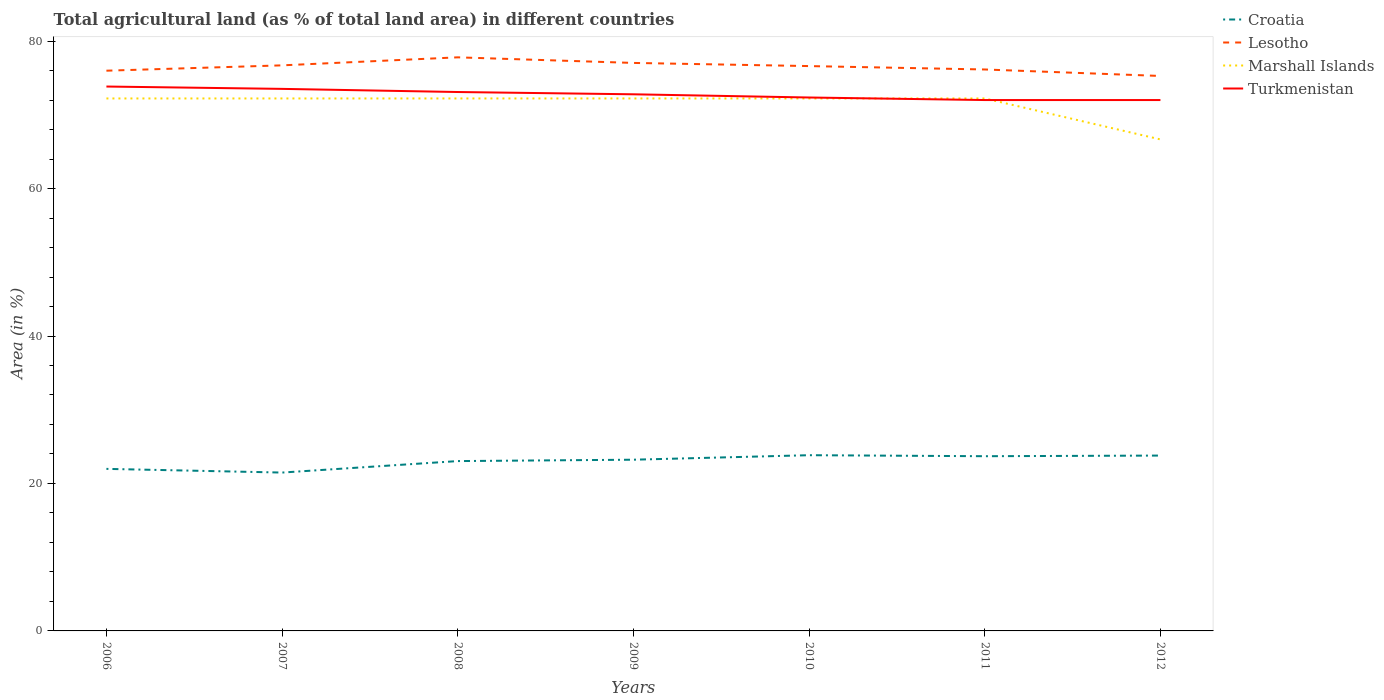Does the line corresponding to Lesotho intersect with the line corresponding to Marshall Islands?
Make the answer very short. No. Across all years, what is the maximum percentage of agricultural land in Marshall Islands?
Your answer should be very brief. 66.67. What is the total percentage of agricultural land in Lesotho in the graph?
Keep it short and to the point. -0.33. What is the difference between the highest and the second highest percentage of agricultural land in Marshall Islands?
Provide a succinct answer. 5.56. What is the difference between the highest and the lowest percentage of agricultural land in Croatia?
Make the answer very short. 5. Is the percentage of agricultural land in Lesotho strictly greater than the percentage of agricultural land in Croatia over the years?
Your answer should be compact. No. How many lines are there?
Offer a terse response. 4. How many years are there in the graph?
Provide a succinct answer. 7. Does the graph contain any zero values?
Offer a terse response. No. How many legend labels are there?
Give a very brief answer. 4. How are the legend labels stacked?
Your response must be concise. Vertical. What is the title of the graph?
Give a very brief answer. Total agricultural land (as % of total land area) in different countries. What is the label or title of the Y-axis?
Offer a very short reply. Area (in %). What is the Area (in %) in Croatia in 2006?
Your answer should be compact. 21.98. What is the Area (in %) of Lesotho in 2006?
Provide a short and direct response. 75.99. What is the Area (in %) of Marshall Islands in 2006?
Your answer should be very brief. 72.22. What is the Area (in %) of Turkmenistan in 2006?
Offer a terse response. 73.84. What is the Area (in %) of Croatia in 2007?
Provide a succinct answer. 21.48. What is the Area (in %) in Lesotho in 2007?
Provide a short and direct response. 76.71. What is the Area (in %) of Marshall Islands in 2007?
Your answer should be very brief. 72.22. What is the Area (in %) in Turkmenistan in 2007?
Offer a very short reply. 73.52. What is the Area (in %) in Croatia in 2008?
Provide a short and direct response. 23.04. What is the Area (in %) in Lesotho in 2008?
Your answer should be very brief. 77.8. What is the Area (in %) in Marshall Islands in 2008?
Your answer should be compact. 72.22. What is the Area (in %) of Turkmenistan in 2008?
Offer a terse response. 73.1. What is the Area (in %) in Croatia in 2009?
Make the answer very short. 23.22. What is the Area (in %) of Lesotho in 2009?
Make the answer very short. 77.04. What is the Area (in %) of Marshall Islands in 2009?
Your answer should be compact. 72.22. What is the Area (in %) in Turkmenistan in 2009?
Your response must be concise. 72.79. What is the Area (in %) of Croatia in 2010?
Ensure brevity in your answer.  23.83. What is the Area (in %) of Lesotho in 2010?
Keep it short and to the point. 76.61. What is the Area (in %) in Marshall Islands in 2010?
Provide a succinct answer. 72.22. What is the Area (in %) in Turkmenistan in 2010?
Offer a very short reply. 72.35. What is the Area (in %) of Croatia in 2011?
Your answer should be compact. 23.7. What is the Area (in %) of Lesotho in 2011?
Make the answer very short. 76.15. What is the Area (in %) of Marshall Islands in 2011?
Keep it short and to the point. 72.22. What is the Area (in %) of Turkmenistan in 2011?
Offer a terse response. 72.01. What is the Area (in %) in Croatia in 2012?
Make the answer very short. 23.78. What is the Area (in %) of Lesotho in 2012?
Your answer should be very brief. 75.27. What is the Area (in %) of Marshall Islands in 2012?
Offer a very short reply. 66.67. What is the Area (in %) of Turkmenistan in 2012?
Your answer should be very brief. 72.01. Across all years, what is the maximum Area (in %) of Croatia?
Give a very brief answer. 23.83. Across all years, what is the maximum Area (in %) in Lesotho?
Make the answer very short. 77.8. Across all years, what is the maximum Area (in %) of Marshall Islands?
Offer a terse response. 72.22. Across all years, what is the maximum Area (in %) in Turkmenistan?
Ensure brevity in your answer.  73.84. Across all years, what is the minimum Area (in %) in Croatia?
Ensure brevity in your answer.  21.48. Across all years, what is the minimum Area (in %) in Lesotho?
Ensure brevity in your answer.  75.27. Across all years, what is the minimum Area (in %) in Marshall Islands?
Provide a short and direct response. 66.67. Across all years, what is the minimum Area (in %) of Turkmenistan?
Offer a very short reply. 72.01. What is the total Area (in %) of Croatia in the graph?
Provide a succinct answer. 161.04. What is the total Area (in %) of Lesotho in the graph?
Offer a terse response. 535.58. What is the total Area (in %) of Marshall Islands in the graph?
Offer a very short reply. 500. What is the total Area (in %) of Turkmenistan in the graph?
Make the answer very short. 509.61. What is the difference between the Area (in %) of Croatia in 2006 and that in 2007?
Provide a succinct answer. 0.5. What is the difference between the Area (in %) in Lesotho in 2006 and that in 2007?
Provide a succinct answer. -0.72. What is the difference between the Area (in %) of Marshall Islands in 2006 and that in 2007?
Your answer should be compact. 0. What is the difference between the Area (in %) of Turkmenistan in 2006 and that in 2007?
Offer a very short reply. 0.32. What is the difference between the Area (in %) in Croatia in 2006 and that in 2008?
Offer a very short reply. -1.06. What is the difference between the Area (in %) of Lesotho in 2006 and that in 2008?
Your response must be concise. -1.81. What is the difference between the Area (in %) of Marshall Islands in 2006 and that in 2008?
Provide a succinct answer. 0. What is the difference between the Area (in %) in Turkmenistan in 2006 and that in 2008?
Keep it short and to the point. 0.74. What is the difference between the Area (in %) of Croatia in 2006 and that in 2009?
Your answer should be very brief. -1.24. What is the difference between the Area (in %) of Lesotho in 2006 and that in 2009?
Keep it short and to the point. -1.05. What is the difference between the Area (in %) in Turkmenistan in 2006 and that in 2009?
Keep it short and to the point. 1.05. What is the difference between the Area (in %) of Croatia in 2006 and that in 2010?
Provide a short and direct response. -1.85. What is the difference between the Area (in %) in Lesotho in 2006 and that in 2010?
Offer a terse response. -0.63. What is the difference between the Area (in %) of Marshall Islands in 2006 and that in 2010?
Keep it short and to the point. 0. What is the difference between the Area (in %) in Turkmenistan in 2006 and that in 2010?
Give a very brief answer. 1.49. What is the difference between the Area (in %) in Croatia in 2006 and that in 2011?
Your answer should be very brief. -1.72. What is the difference between the Area (in %) in Lesotho in 2006 and that in 2011?
Provide a short and direct response. -0.16. What is the difference between the Area (in %) of Marshall Islands in 2006 and that in 2011?
Give a very brief answer. 0. What is the difference between the Area (in %) in Turkmenistan in 2006 and that in 2011?
Keep it short and to the point. 1.83. What is the difference between the Area (in %) in Croatia in 2006 and that in 2012?
Make the answer very short. -1.8. What is the difference between the Area (in %) of Lesotho in 2006 and that in 2012?
Provide a short and direct response. 0.71. What is the difference between the Area (in %) in Marshall Islands in 2006 and that in 2012?
Keep it short and to the point. 5.56. What is the difference between the Area (in %) in Turkmenistan in 2006 and that in 2012?
Your answer should be compact. 1.83. What is the difference between the Area (in %) of Croatia in 2007 and that in 2008?
Ensure brevity in your answer.  -1.56. What is the difference between the Area (in %) in Lesotho in 2007 and that in 2008?
Provide a succinct answer. -1.09. What is the difference between the Area (in %) in Marshall Islands in 2007 and that in 2008?
Give a very brief answer. 0. What is the difference between the Area (in %) in Turkmenistan in 2007 and that in 2008?
Your answer should be compact. 0.43. What is the difference between the Area (in %) of Croatia in 2007 and that in 2009?
Make the answer very short. -1.74. What is the difference between the Area (in %) of Lesotho in 2007 and that in 2009?
Your answer should be very brief. -0.33. What is the difference between the Area (in %) in Turkmenistan in 2007 and that in 2009?
Keep it short and to the point. 0.73. What is the difference between the Area (in %) of Croatia in 2007 and that in 2010?
Provide a succinct answer. -2.36. What is the difference between the Area (in %) in Lesotho in 2007 and that in 2010?
Ensure brevity in your answer.  0.1. What is the difference between the Area (in %) of Marshall Islands in 2007 and that in 2010?
Your answer should be compact. 0. What is the difference between the Area (in %) of Turkmenistan in 2007 and that in 2010?
Your answer should be compact. 1.17. What is the difference between the Area (in %) in Croatia in 2007 and that in 2011?
Provide a short and direct response. -2.22. What is the difference between the Area (in %) of Lesotho in 2007 and that in 2011?
Your answer should be very brief. 0.56. What is the difference between the Area (in %) of Marshall Islands in 2007 and that in 2011?
Your answer should be compact. 0. What is the difference between the Area (in %) in Turkmenistan in 2007 and that in 2011?
Your answer should be compact. 1.52. What is the difference between the Area (in %) of Croatia in 2007 and that in 2012?
Your answer should be very brief. -2.31. What is the difference between the Area (in %) in Lesotho in 2007 and that in 2012?
Provide a succinct answer. 1.44. What is the difference between the Area (in %) of Marshall Islands in 2007 and that in 2012?
Keep it short and to the point. 5.56. What is the difference between the Area (in %) of Turkmenistan in 2007 and that in 2012?
Your answer should be compact. 1.52. What is the difference between the Area (in %) of Croatia in 2008 and that in 2009?
Make the answer very short. -0.19. What is the difference between the Area (in %) of Lesotho in 2008 and that in 2009?
Make the answer very short. 0.76. What is the difference between the Area (in %) of Turkmenistan in 2008 and that in 2009?
Offer a terse response. 0.31. What is the difference between the Area (in %) of Croatia in 2008 and that in 2010?
Provide a succinct answer. -0.8. What is the difference between the Area (in %) of Lesotho in 2008 and that in 2010?
Provide a succinct answer. 1.19. What is the difference between the Area (in %) of Turkmenistan in 2008 and that in 2010?
Your response must be concise. 0.74. What is the difference between the Area (in %) of Croatia in 2008 and that in 2011?
Provide a succinct answer. -0.66. What is the difference between the Area (in %) of Lesotho in 2008 and that in 2011?
Ensure brevity in your answer.  1.65. What is the difference between the Area (in %) in Marshall Islands in 2008 and that in 2011?
Your response must be concise. 0. What is the difference between the Area (in %) of Turkmenistan in 2008 and that in 2011?
Provide a succinct answer. 1.09. What is the difference between the Area (in %) of Croatia in 2008 and that in 2012?
Your answer should be very brief. -0.75. What is the difference between the Area (in %) of Lesotho in 2008 and that in 2012?
Your response must be concise. 2.53. What is the difference between the Area (in %) of Marshall Islands in 2008 and that in 2012?
Your answer should be very brief. 5.56. What is the difference between the Area (in %) of Turkmenistan in 2008 and that in 2012?
Offer a very short reply. 1.09. What is the difference between the Area (in %) of Croatia in 2009 and that in 2010?
Provide a short and direct response. -0.61. What is the difference between the Area (in %) of Lesotho in 2009 and that in 2010?
Offer a very short reply. 0.43. What is the difference between the Area (in %) of Turkmenistan in 2009 and that in 2010?
Your response must be concise. 0.44. What is the difference between the Area (in %) in Croatia in 2009 and that in 2011?
Make the answer very short. -0.47. What is the difference between the Area (in %) in Lesotho in 2009 and that in 2011?
Ensure brevity in your answer.  0.89. What is the difference between the Area (in %) in Turkmenistan in 2009 and that in 2011?
Offer a very short reply. 0.78. What is the difference between the Area (in %) of Croatia in 2009 and that in 2012?
Offer a very short reply. -0.56. What is the difference between the Area (in %) in Lesotho in 2009 and that in 2012?
Your answer should be compact. 1.77. What is the difference between the Area (in %) in Marshall Islands in 2009 and that in 2012?
Offer a terse response. 5.56. What is the difference between the Area (in %) in Turkmenistan in 2009 and that in 2012?
Offer a terse response. 0.78. What is the difference between the Area (in %) in Croatia in 2010 and that in 2011?
Give a very brief answer. 0.14. What is the difference between the Area (in %) in Lesotho in 2010 and that in 2011?
Provide a short and direct response. 0.46. What is the difference between the Area (in %) of Marshall Islands in 2010 and that in 2011?
Ensure brevity in your answer.  0. What is the difference between the Area (in %) in Turkmenistan in 2010 and that in 2011?
Offer a very short reply. 0.34. What is the difference between the Area (in %) of Croatia in 2010 and that in 2012?
Provide a succinct answer. 0.05. What is the difference between the Area (in %) of Lesotho in 2010 and that in 2012?
Give a very brief answer. 1.34. What is the difference between the Area (in %) of Marshall Islands in 2010 and that in 2012?
Provide a short and direct response. 5.56. What is the difference between the Area (in %) in Turkmenistan in 2010 and that in 2012?
Provide a short and direct response. 0.34. What is the difference between the Area (in %) in Croatia in 2011 and that in 2012?
Ensure brevity in your answer.  -0.09. What is the difference between the Area (in %) in Lesotho in 2011 and that in 2012?
Provide a short and direct response. 0.88. What is the difference between the Area (in %) of Marshall Islands in 2011 and that in 2012?
Ensure brevity in your answer.  5.56. What is the difference between the Area (in %) in Turkmenistan in 2011 and that in 2012?
Give a very brief answer. 0. What is the difference between the Area (in %) of Croatia in 2006 and the Area (in %) of Lesotho in 2007?
Offer a very short reply. -54.73. What is the difference between the Area (in %) of Croatia in 2006 and the Area (in %) of Marshall Islands in 2007?
Offer a very short reply. -50.24. What is the difference between the Area (in %) of Croatia in 2006 and the Area (in %) of Turkmenistan in 2007?
Your answer should be very brief. -51.54. What is the difference between the Area (in %) in Lesotho in 2006 and the Area (in %) in Marshall Islands in 2007?
Provide a short and direct response. 3.77. What is the difference between the Area (in %) in Lesotho in 2006 and the Area (in %) in Turkmenistan in 2007?
Provide a succinct answer. 2.47. What is the difference between the Area (in %) in Marshall Islands in 2006 and the Area (in %) in Turkmenistan in 2007?
Your answer should be compact. -1.3. What is the difference between the Area (in %) in Croatia in 2006 and the Area (in %) in Lesotho in 2008?
Provide a succinct answer. -55.82. What is the difference between the Area (in %) of Croatia in 2006 and the Area (in %) of Marshall Islands in 2008?
Your answer should be compact. -50.24. What is the difference between the Area (in %) of Croatia in 2006 and the Area (in %) of Turkmenistan in 2008?
Your answer should be very brief. -51.12. What is the difference between the Area (in %) in Lesotho in 2006 and the Area (in %) in Marshall Islands in 2008?
Your answer should be compact. 3.77. What is the difference between the Area (in %) in Lesotho in 2006 and the Area (in %) in Turkmenistan in 2008?
Your answer should be very brief. 2.89. What is the difference between the Area (in %) in Marshall Islands in 2006 and the Area (in %) in Turkmenistan in 2008?
Provide a succinct answer. -0.87. What is the difference between the Area (in %) of Croatia in 2006 and the Area (in %) of Lesotho in 2009?
Your response must be concise. -55.06. What is the difference between the Area (in %) in Croatia in 2006 and the Area (in %) in Marshall Islands in 2009?
Your answer should be very brief. -50.24. What is the difference between the Area (in %) in Croatia in 2006 and the Area (in %) in Turkmenistan in 2009?
Your response must be concise. -50.81. What is the difference between the Area (in %) of Lesotho in 2006 and the Area (in %) of Marshall Islands in 2009?
Ensure brevity in your answer.  3.77. What is the difference between the Area (in %) of Lesotho in 2006 and the Area (in %) of Turkmenistan in 2009?
Your answer should be compact. 3.2. What is the difference between the Area (in %) in Marshall Islands in 2006 and the Area (in %) in Turkmenistan in 2009?
Make the answer very short. -0.57. What is the difference between the Area (in %) of Croatia in 2006 and the Area (in %) of Lesotho in 2010?
Give a very brief answer. -54.63. What is the difference between the Area (in %) in Croatia in 2006 and the Area (in %) in Marshall Islands in 2010?
Provide a short and direct response. -50.24. What is the difference between the Area (in %) of Croatia in 2006 and the Area (in %) of Turkmenistan in 2010?
Your response must be concise. -50.37. What is the difference between the Area (in %) of Lesotho in 2006 and the Area (in %) of Marshall Islands in 2010?
Ensure brevity in your answer.  3.77. What is the difference between the Area (in %) in Lesotho in 2006 and the Area (in %) in Turkmenistan in 2010?
Offer a terse response. 3.64. What is the difference between the Area (in %) in Marshall Islands in 2006 and the Area (in %) in Turkmenistan in 2010?
Keep it short and to the point. -0.13. What is the difference between the Area (in %) in Croatia in 2006 and the Area (in %) in Lesotho in 2011?
Offer a terse response. -54.17. What is the difference between the Area (in %) of Croatia in 2006 and the Area (in %) of Marshall Islands in 2011?
Provide a short and direct response. -50.24. What is the difference between the Area (in %) in Croatia in 2006 and the Area (in %) in Turkmenistan in 2011?
Your answer should be compact. -50.03. What is the difference between the Area (in %) of Lesotho in 2006 and the Area (in %) of Marshall Islands in 2011?
Keep it short and to the point. 3.77. What is the difference between the Area (in %) in Lesotho in 2006 and the Area (in %) in Turkmenistan in 2011?
Your answer should be compact. 3.98. What is the difference between the Area (in %) in Marshall Islands in 2006 and the Area (in %) in Turkmenistan in 2011?
Offer a very short reply. 0.22. What is the difference between the Area (in %) of Croatia in 2006 and the Area (in %) of Lesotho in 2012?
Provide a short and direct response. -53.29. What is the difference between the Area (in %) of Croatia in 2006 and the Area (in %) of Marshall Islands in 2012?
Provide a short and direct response. -44.69. What is the difference between the Area (in %) of Croatia in 2006 and the Area (in %) of Turkmenistan in 2012?
Provide a short and direct response. -50.03. What is the difference between the Area (in %) of Lesotho in 2006 and the Area (in %) of Marshall Islands in 2012?
Provide a succinct answer. 9.32. What is the difference between the Area (in %) of Lesotho in 2006 and the Area (in %) of Turkmenistan in 2012?
Offer a terse response. 3.98. What is the difference between the Area (in %) in Marshall Islands in 2006 and the Area (in %) in Turkmenistan in 2012?
Offer a very short reply. 0.22. What is the difference between the Area (in %) in Croatia in 2007 and the Area (in %) in Lesotho in 2008?
Keep it short and to the point. -56.32. What is the difference between the Area (in %) in Croatia in 2007 and the Area (in %) in Marshall Islands in 2008?
Provide a succinct answer. -50.74. What is the difference between the Area (in %) of Croatia in 2007 and the Area (in %) of Turkmenistan in 2008?
Offer a terse response. -51.62. What is the difference between the Area (in %) in Lesotho in 2007 and the Area (in %) in Marshall Islands in 2008?
Offer a terse response. 4.49. What is the difference between the Area (in %) in Lesotho in 2007 and the Area (in %) in Turkmenistan in 2008?
Ensure brevity in your answer.  3.62. What is the difference between the Area (in %) of Marshall Islands in 2007 and the Area (in %) of Turkmenistan in 2008?
Your response must be concise. -0.87. What is the difference between the Area (in %) in Croatia in 2007 and the Area (in %) in Lesotho in 2009?
Provide a short and direct response. -55.56. What is the difference between the Area (in %) of Croatia in 2007 and the Area (in %) of Marshall Islands in 2009?
Offer a very short reply. -50.74. What is the difference between the Area (in %) in Croatia in 2007 and the Area (in %) in Turkmenistan in 2009?
Your answer should be very brief. -51.31. What is the difference between the Area (in %) in Lesotho in 2007 and the Area (in %) in Marshall Islands in 2009?
Make the answer very short. 4.49. What is the difference between the Area (in %) in Lesotho in 2007 and the Area (in %) in Turkmenistan in 2009?
Provide a succinct answer. 3.93. What is the difference between the Area (in %) of Marshall Islands in 2007 and the Area (in %) of Turkmenistan in 2009?
Your answer should be compact. -0.57. What is the difference between the Area (in %) in Croatia in 2007 and the Area (in %) in Lesotho in 2010?
Your response must be concise. -55.13. What is the difference between the Area (in %) in Croatia in 2007 and the Area (in %) in Marshall Islands in 2010?
Offer a very short reply. -50.74. What is the difference between the Area (in %) in Croatia in 2007 and the Area (in %) in Turkmenistan in 2010?
Your answer should be compact. -50.87. What is the difference between the Area (in %) in Lesotho in 2007 and the Area (in %) in Marshall Islands in 2010?
Give a very brief answer. 4.49. What is the difference between the Area (in %) in Lesotho in 2007 and the Area (in %) in Turkmenistan in 2010?
Give a very brief answer. 4.36. What is the difference between the Area (in %) in Marshall Islands in 2007 and the Area (in %) in Turkmenistan in 2010?
Offer a terse response. -0.13. What is the difference between the Area (in %) of Croatia in 2007 and the Area (in %) of Lesotho in 2011?
Offer a terse response. -54.67. What is the difference between the Area (in %) in Croatia in 2007 and the Area (in %) in Marshall Islands in 2011?
Your response must be concise. -50.74. What is the difference between the Area (in %) in Croatia in 2007 and the Area (in %) in Turkmenistan in 2011?
Your answer should be compact. -50.53. What is the difference between the Area (in %) of Lesotho in 2007 and the Area (in %) of Marshall Islands in 2011?
Ensure brevity in your answer.  4.49. What is the difference between the Area (in %) of Lesotho in 2007 and the Area (in %) of Turkmenistan in 2011?
Make the answer very short. 4.71. What is the difference between the Area (in %) in Marshall Islands in 2007 and the Area (in %) in Turkmenistan in 2011?
Ensure brevity in your answer.  0.22. What is the difference between the Area (in %) in Croatia in 2007 and the Area (in %) in Lesotho in 2012?
Make the answer very short. -53.79. What is the difference between the Area (in %) in Croatia in 2007 and the Area (in %) in Marshall Islands in 2012?
Keep it short and to the point. -45.19. What is the difference between the Area (in %) in Croatia in 2007 and the Area (in %) in Turkmenistan in 2012?
Your response must be concise. -50.53. What is the difference between the Area (in %) in Lesotho in 2007 and the Area (in %) in Marshall Islands in 2012?
Ensure brevity in your answer.  10.05. What is the difference between the Area (in %) of Lesotho in 2007 and the Area (in %) of Turkmenistan in 2012?
Your answer should be compact. 4.71. What is the difference between the Area (in %) of Marshall Islands in 2007 and the Area (in %) of Turkmenistan in 2012?
Offer a terse response. 0.22. What is the difference between the Area (in %) of Croatia in 2008 and the Area (in %) of Lesotho in 2009?
Ensure brevity in your answer.  -54.01. What is the difference between the Area (in %) of Croatia in 2008 and the Area (in %) of Marshall Islands in 2009?
Make the answer very short. -49.19. What is the difference between the Area (in %) of Croatia in 2008 and the Area (in %) of Turkmenistan in 2009?
Give a very brief answer. -49.75. What is the difference between the Area (in %) of Lesotho in 2008 and the Area (in %) of Marshall Islands in 2009?
Provide a succinct answer. 5.58. What is the difference between the Area (in %) in Lesotho in 2008 and the Area (in %) in Turkmenistan in 2009?
Provide a short and direct response. 5.01. What is the difference between the Area (in %) in Marshall Islands in 2008 and the Area (in %) in Turkmenistan in 2009?
Provide a short and direct response. -0.57. What is the difference between the Area (in %) in Croatia in 2008 and the Area (in %) in Lesotho in 2010?
Your answer should be very brief. -53.58. What is the difference between the Area (in %) in Croatia in 2008 and the Area (in %) in Marshall Islands in 2010?
Make the answer very short. -49.19. What is the difference between the Area (in %) of Croatia in 2008 and the Area (in %) of Turkmenistan in 2010?
Keep it short and to the point. -49.32. What is the difference between the Area (in %) in Lesotho in 2008 and the Area (in %) in Marshall Islands in 2010?
Offer a terse response. 5.58. What is the difference between the Area (in %) in Lesotho in 2008 and the Area (in %) in Turkmenistan in 2010?
Give a very brief answer. 5.45. What is the difference between the Area (in %) of Marshall Islands in 2008 and the Area (in %) of Turkmenistan in 2010?
Your answer should be compact. -0.13. What is the difference between the Area (in %) in Croatia in 2008 and the Area (in %) in Lesotho in 2011?
Give a very brief answer. -53.12. What is the difference between the Area (in %) of Croatia in 2008 and the Area (in %) of Marshall Islands in 2011?
Ensure brevity in your answer.  -49.19. What is the difference between the Area (in %) in Croatia in 2008 and the Area (in %) in Turkmenistan in 2011?
Offer a very short reply. -48.97. What is the difference between the Area (in %) in Lesotho in 2008 and the Area (in %) in Marshall Islands in 2011?
Give a very brief answer. 5.58. What is the difference between the Area (in %) in Lesotho in 2008 and the Area (in %) in Turkmenistan in 2011?
Offer a very short reply. 5.79. What is the difference between the Area (in %) in Marshall Islands in 2008 and the Area (in %) in Turkmenistan in 2011?
Offer a very short reply. 0.22. What is the difference between the Area (in %) in Croatia in 2008 and the Area (in %) in Lesotho in 2012?
Keep it short and to the point. -52.24. What is the difference between the Area (in %) in Croatia in 2008 and the Area (in %) in Marshall Islands in 2012?
Your response must be concise. -43.63. What is the difference between the Area (in %) in Croatia in 2008 and the Area (in %) in Turkmenistan in 2012?
Provide a short and direct response. -48.97. What is the difference between the Area (in %) in Lesotho in 2008 and the Area (in %) in Marshall Islands in 2012?
Ensure brevity in your answer.  11.13. What is the difference between the Area (in %) of Lesotho in 2008 and the Area (in %) of Turkmenistan in 2012?
Your answer should be compact. 5.79. What is the difference between the Area (in %) in Marshall Islands in 2008 and the Area (in %) in Turkmenistan in 2012?
Ensure brevity in your answer.  0.22. What is the difference between the Area (in %) in Croatia in 2009 and the Area (in %) in Lesotho in 2010?
Provide a succinct answer. -53.39. What is the difference between the Area (in %) in Croatia in 2009 and the Area (in %) in Marshall Islands in 2010?
Give a very brief answer. -49. What is the difference between the Area (in %) in Croatia in 2009 and the Area (in %) in Turkmenistan in 2010?
Give a very brief answer. -49.13. What is the difference between the Area (in %) in Lesotho in 2009 and the Area (in %) in Marshall Islands in 2010?
Keep it short and to the point. 4.82. What is the difference between the Area (in %) of Lesotho in 2009 and the Area (in %) of Turkmenistan in 2010?
Give a very brief answer. 4.69. What is the difference between the Area (in %) in Marshall Islands in 2009 and the Area (in %) in Turkmenistan in 2010?
Provide a short and direct response. -0.13. What is the difference between the Area (in %) of Croatia in 2009 and the Area (in %) of Lesotho in 2011?
Your response must be concise. -52.93. What is the difference between the Area (in %) of Croatia in 2009 and the Area (in %) of Marshall Islands in 2011?
Keep it short and to the point. -49. What is the difference between the Area (in %) of Croatia in 2009 and the Area (in %) of Turkmenistan in 2011?
Your answer should be compact. -48.78. What is the difference between the Area (in %) in Lesotho in 2009 and the Area (in %) in Marshall Islands in 2011?
Your answer should be compact. 4.82. What is the difference between the Area (in %) in Lesotho in 2009 and the Area (in %) in Turkmenistan in 2011?
Provide a short and direct response. 5.04. What is the difference between the Area (in %) of Marshall Islands in 2009 and the Area (in %) of Turkmenistan in 2011?
Ensure brevity in your answer.  0.22. What is the difference between the Area (in %) in Croatia in 2009 and the Area (in %) in Lesotho in 2012?
Ensure brevity in your answer.  -52.05. What is the difference between the Area (in %) in Croatia in 2009 and the Area (in %) in Marshall Islands in 2012?
Make the answer very short. -43.44. What is the difference between the Area (in %) of Croatia in 2009 and the Area (in %) of Turkmenistan in 2012?
Offer a very short reply. -48.78. What is the difference between the Area (in %) in Lesotho in 2009 and the Area (in %) in Marshall Islands in 2012?
Your answer should be compact. 10.38. What is the difference between the Area (in %) in Lesotho in 2009 and the Area (in %) in Turkmenistan in 2012?
Give a very brief answer. 5.04. What is the difference between the Area (in %) of Marshall Islands in 2009 and the Area (in %) of Turkmenistan in 2012?
Your answer should be very brief. 0.22. What is the difference between the Area (in %) in Croatia in 2010 and the Area (in %) in Lesotho in 2011?
Offer a terse response. -52.32. What is the difference between the Area (in %) in Croatia in 2010 and the Area (in %) in Marshall Islands in 2011?
Ensure brevity in your answer.  -48.39. What is the difference between the Area (in %) in Croatia in 2010 and the Area (in %) in Turkmenistan in 2011?
Make the answer very short. -48.17. What is the difference between the Area (in %) of Lesotho in 2010 and the Area (in %) of Marshall Islands in 2011?
Your response must be concise. 4.39. What is the difference between the Area (in %) of Lesotho in 2010 and the Area (in %) of Turkmenistan in 2011?
Your answer should be very brief. 4.61. What is the difference between the Area (in %) in Marshall Islands in 2010 and the Area (in %) in Turkmenistan in 2011?
Make the answer very short. 0.22. What is the difference between the Area (in %) in Croatia in 2010 and the Area (in %) in Lesotho in 2012?
Keep it short and to the point. -51.44. What is the difference between the Area (in %) of Croatia in 2010 and the Area (in %) of Marshall Islands in 2012?
Ensure brevity in your answer.  -42.83. What is the difference between the Area (in %) of Croatia in 2010 and the Area (in %) of Turkmenistan in 2012?
Offer a very short reply. -48.17. What is the difference between the Area (in %) of Lesotho in 2010 and the Area (in %) of Marshall Islands in 2012?
Your answer should be compact. 9.95. What is the difference between the Area (in %) in Lesotho in 2010 and the Area (in %) in Turkmenistan in 2012?
Keep it short and to the point. 4.61. What is the difference between the Area (in %) in Marshall Islands in 2010 and the Area (in %) in Turkmenistan in 2012?
Your answer should be very brief. 0.22. What is the difference between the Area (in %) of Croatia in 2011 and the Area (in %) of Lesotho in 2012?
Keep it short and to the point. -51.58. What is the difference between the Area (in %) in Croatia in 2011 and the Area (in %) in Marshall Islands in 2012?
Provide a short and direct response. -42.97. What is the difference between the Area (in %) of Croatia in 2011 and the Area (in %) of Turkmenistan in 2012?
Offer a terse response. -48.31. What is the difference between the Area (in %) in Lesotho in 2011 and the Area (in %) in Marshall Islands in 2012?
Your answer should be very brief. 9.49. What is the difference between the Area (in %) of Lesotho in 2011 and the Area (in %) of Turkmenistan in 2012?
Provide a short and direct response. 4.15. What is the difference between the Area (in %) in Marshall Islands in 2011 and the Area (in %) in Turkmenistan in 2012?
Keep it short and to the point. 0.22. What is the average Area (in %) in Croatia per year?
Offer a very short reply. 23.01. What is the average Area (in %) in Lesotho per year?
Provide a succinct answer. 76.51. What is the average Area (in %) in Marshall Islands per year?
Make the answer very short. 71.43. What is the average Area (in %) of Turkmenistan per year?
Offer a terse response. 72.8. In the year 2006, what is the difference between the Area (in %) of Croatia and Area (in %) of Lesotho?
Make the answer very short. -54.01. In the year 2006, what is the difference between the Area (in %) of Croatia and Area (in %) of Marshall Islands?
Ensure brevity in your answer.  -50.24. In the year 2006, what is the difference between the Area (in %) of Croatia and Area (in %) of Turkmenistan?
Offer a very short reply. -51.86. In the year 2006, what is the difference between the Area (in %) of Lesotho and Area (in %) of Marshall Islands?
Give a very brief answer. 3.77. In the year 2006, what is the difference between the Area (in %) in Lesotho and Area (in %) in Turkmenistan?
Your answer should be compact. 2.15. In the year 2006, what is the difference between the Area (in %) in Marshall Islands and Area (in %) in Turkmenistan?
Provide a short and direct response. -1.62. In the year 2007, what is the difference between the Area (in %) in Croatia and Area (in %) in Lesotho?
Offer a terse response. -55.23. In the year 2007, what is the difference between the Area (in %) in Croatia and Area (in %) in Marshall Islands?
Your answer should be very brief. -50.74. In the year 2007, what is the difference between the Area (in %) in Croatia and Area (in %) in Turkmenistan?
Keep it short and to the point. -52.04. In the year 2007, what is the difference between the Area (in %) of Lesotho and Area (in %) of Marshall Islands?
Make the answer very short. 4.49. In the year 2007, what is the difference between the Area (in %) of Lesotho and Area (in %) of Turkmenistan?
Your response must be concise. 3.19. In the year 2007, what is the difference between the Area (in %) in Marshall Islands and Area (in %) in Turkmenistan?
Offer a very short reply. -1.3. In the year 2008, what is the difference between the Area (in %) of Croatia and Area (in %) of Lesotho?
Your answer should be very brief. -54.76. In the year 2008, what is the difference between the Area (in %) in Croatia and Area (in %) in Marshall Islands?
Ensure brevity in your answer.  -49.19. In the year 2008, what is the difference between the Area (in %) of Croatia and Area (in %) of Turkmenistan?
Provide a succinct answer. -50.06. In the year 2008, what is the difference between the Area (in %) in Lesotho and Area (in %) in Marshall Islands?
Your answer should be compact. 5.58. In the year 2008, what is the difference between the Area (in %) of Lesotho and Area (in %) of Turkmenistan?
Your answer should be compact. 4.7. In the year 2008, what is the difference between the Area (in %) in Marshall Islands and Area (in %) in Turkmenistan?
Keep it short and to the point. -0.87. In the year 2009, what is the difference between the Area (in %) of Croatia and Area (in %) of Lesotho?
Offer a terse response. -53.82. In the year 2009, what is the difference between the Area (in %) of Croatia and Area (in %) of Marshall Islands?
Your response must be concise. -49. In the year 2009, what is the difference between the Area (in %) of Croatia and Area (in %) of Turkmenistan?
Your answer should be compact. -49.56. In the year 2009, what is the difference between the Area (in %) in Lesotho and Area (in %) in Marshall Islands?
Your response must be concise. 4.82. In the year 2009, what is the difference between the Area (in %) in Lesotho and Area (in %) in Turkmenistan?
Your answer should be compact. 4.25. In the year 2009, what is the difference between the Area (in %) in Marshall Islands and Area (in %) in Turkmenistan?
Keep it short and to the point. -0.57. In the year 2010, what is the difference between the Area (in %) in Croatia and Area (in %) in Lesotho?
Ensure brevity in your answer.  -52.78. In the year 2010, what is the difference between the Area (in %) in Croatia and Area (in %) in Marshall Islands?
Ensure brevity in your answer.  -48.39. In the year 2010, what is the difference between the Area (in %) of Croatia and Area (in %) of Turkmenistan?
Offer a terse response. -48.52. In the year 2010, what is the difference between the Area (in %) in Lesotho and Area (in %) in Marshall Islands?
Offer a very short reply. 4.39. In the year 2010, what is the difference between the Area (in %) in Lesotho and Area (in %) in Turkmenistan?
Your answer should be very brief. 4.26. In the year 2010, what is the difference between the Area (in %) of Marshall Islands and Area (in %) of Turkmenistan?
Ensure brevity in your answer.  -0.13. In the year 2011, what is the difference between the Area (in %) in Croatia and Area (in %) in Lesotho?
Give a very brief answer. -52.46. In the year 2011, what is the difference between the Area (in %) in Croatia and Area (in %) in Marshall Islands?
Offer a terse response. -48.52. In the year 2011, what is the difference between the Area (in %) of Croatia and Area (in %) of Turkmenistan?
Provide a short and direct response. -48.31. In the year 2011, what is the difference between the Area (in %) of Lesotho and Area (in %) of Marshall Islands?
Offer a very short reply. 3.93. In the year 2011, what is the difference between the Area (in %) in Lesotho and Area (in %) in Turkmenistan?
Offer a terse response. 4.15. In the year 2011, what is the difference between the Area (in %) of Marshall Islands and Area (in %) of Turkmenistan?
Your response must be concise. 0.22. In the year 2012, what is the difference between the Area (in %) in Croatia and Area (in %) in Lesotho?
Offer a very short reply. -51.49. In the year 2012, what is the difference between the Area (in %) in Croatia and Area (in %) in Marshall Islands?
Make the answer very short. -42.88. In the year 2012, what is the difference between the Area (in %) in Croatia and Area (in %) in Turkmenistan?
Give a very brief answer. -48.22. In the year 2012, what is the difference between the Area (in %) of Lesotho and Area (in %) of Marshall Islands?
Provide a short and direct response. 8.61. In the year 2012, what is the difference between the Area (in %) of Lesotho and Area (in %) of Turkmenistan?
Provide a short and direct response. 3.27. In the year 2012, what is the difference between the Area (in %) of Marshall Islands and Area (in %) of Turkmenistan?
Offer a terse response. -5.34. What is the ratio of the Area (in %) of Croatia in 2006 to that in 2007?
Keep it short and to the point. 1.02. What is the ratio of the Area (in %) in Lesotho in 2006 to that in 2007?
Your response must be concise. 0.99. What is the ratio of the Area (in %) in Croatia in 2006 to that in 2008?
Your response must be concise. 0.95. What is the ratio of the Area (in %) of Lesotho in 2006 to that in 2008?
Provide a succinct answer. 0.98. What is the ratio of the Area (in %) in Turkmenistan in 2006 to that in 2008?
Give a very brief answer. 1.01. What is the ratio of the Area (in %) of Croatia in 2006 to that in 2009?
Your response must be concise. 0.95. What is the ratio of the Area (in %) of Lesotho in 2006 to that in 2009?
Provide a short and direct response. 0.99. What is the ratio of the Area (in %) of Marshall Islands in 2006 to that in 2009?
Keep it short and to the point. 1. What is the ratio of the Area (in %) of Turkmenistan in 2006 to that in 2009?
Give a very brief answer. 1.01. What is the ratio of the Area (in %) of Croatia in 2006 to that in 2010?
Your answer should be compact. 0.92. What is the ratio of the Area (in %) in Marshall Islands in 2006 to that in 2010?
Provide a succinct answer. 1. What is the ratio of the Area (in %) in Turkmenistan in 2006 to that in 2010?
Your response must be concise. 1.02. What is the ratio of the Area (in %) of Croatia in 2006 to that in 2011?
Make the answer very short. 0.93. What is the ratio of the Area (in %) of Turkmenistan in 2006 to that in 2011?
Give a very brief answer. 1.03. What is the ratio of the Area (in %) in Croatia in 2006 to that in 2012?
Ensure brevity in your answer.  0.92. What is the ratio of the Area (in %) of Lesotho in 2006 to that in 2012?
Provide a succinct answer. 1.01. What is the ratio of the Area (in %) in Marshall Islands in 2006 to that in 2012?
Your response must be concise. 1.08. What is the ratio of the Area (in %) in Turkmenistan in 2006 to that in 2012?
Offer a very short reply. 1.03. What is the ratio of the Area (in %) of Croatia in 2007 to that in 2008?
Offer a very short reply. 0.93. What is the ratio of the Area (in %) of Lesotho in 2007 to that in 2008?
Offer a very short reply. 0.99. What is the ratio of the Area (in %) of Turkmenistan in 2007 to that in 2008?
Give a very brief answer. 1.01. What is the ratio of the Area (in %) in Croatia in 2007 to that in 2009?
Your response must be concise. 0.92. What is the ratio of the Area (in %) in Turkmenistan in 2007 to that in 2009?
Provide a succinct answer. 1.01. What is the ratio of the Area (in %) of Croatia in 2007 to that in 2010?
Your response must be concise. 0.9. What is the ratio of the Area (in %) of Turkmenistan in 2007 to that in 2010?
Offer a very short reply. 1.02. What is the ratio of the Area (in %) in Croatia in 2007 to that in 2011?
Provide a succinct answer. 0.91. What is the ratio of the Area (in %) in Lesotho in 2007 to that in 2011?
Offer a very short reply. 1.01. What is the ratio of the Area (in %) in Croatia in 2007 to that in 2012?
Provide a short and direct response. 0.9. What is the ratio of the Area (in %) of Lesotho in 2007 to that in 2012?
Provide a short and direct response. 1.02. What is the ratio of the Area (in %) of Marshall Islands in 2007 to that in 2012?
Offer a terse response. 1.08. What is the ratio of the Area (in %) in Croatia in 2008 to that in 2009?
Provide a succinct answer. 0.99. What is the ratio of the Area (in %) of Lesotho in 2008 to that in 2009?
Give a very brief answer. 1.01. What is the ratio of the Area (in %) in Croatia in 2008 to that in 2010?
Make the answer very short. 0.97. What is the ratio of the Area (in %) of Lesotho in 2008 to that in 2010?
Your answer should be very brief. 1.02. What is the ratio of the Area (in %) of Turkmenistan in 2008 to that in 2010?
Give a very brief answer. 1.01. What is the ratio of the Area (in %) in Croatia in 2008 to that in 2011?
Keep it short and to the point. 0.97. What is the ratio of the Area (in %) in Lesotho in 2008 to that in 2011?
Your answer should be very brief. 1.02. What is the ratio of the Area (in %) of Marshall Islands in 2008 to that in 2011?
Your answer should be compact. 1. What is the ratio of the Area (in %) of Turkmenistan in 2008 to that in 2011?
Give a very brief answer. 1.02. What is the ratio of the Area (in %) of Croatia in 2008 to that in 2012?
Keep it short and to the point. 0.97. What is the ratio of the Area (in %) in Lesotho in 2008 to that in 2012?
Your response must be concise. 1.03. What is the ratio of the Area (in %) of Turkmenistan in 2008 to that in 2012?
Ensure brevity in your answer.  1.02. What is the ratio of the Area (in %) of Croatia in 2009 to that in 2010?
Provide a succinct answer. 0.97. What is the ratio of the Area (in %) in Lesotho in 2009 to that in 2010?
Offer a terse response. 1.01. What is the ratio of the Area (in %) in Croatia in 2009 to that in 2011?
Your answer should be compact. 0.98. What is the ratio of the Area (in %) of Lesotho in 2009 to that in 2011?
Make the answer very short. 1.01. What is the ratio of the Area (in %) in Turkmenistan in 2009 to that in 2011?
Your answer should be very brief. 1.01. What is the ratio of the Area (in %) in Croatia in 2009 to that in 2012?
Your answer should be very brief. 0.98. What is the ratio of the Area (in %) of Lesotho in 2009 to that in 2012?
Provide a short and direct response. 1.02. What is the ratio of the Area (in %) of Turkmenistan in 2009 to that in 2012?
Ensure brevity in your answer.  1.01. What is the ratio of the Area (in %) in Croatia in 2010 to that in 2011?
Provide a short and direct response. 1.01. What is the ratio of the Area (in %) of Lesotho in 2010 to that in 2011?
Give a very brief answer. 1.01. What is the ratio of the Area (in %) of Croatia in 2010 to that in 2012?
Provide a short and direct response. 1. What is the ratio of the Area (in %) of Lesotho in 2010 to that in 2012?
Offer a terse response. 1.02. What is the ratio of the Area (in %) in Marshall Islands in 2010 to that in 2012?
Offer a terse response. 1.08. What is the ratio of the Area (in %) in Turkmenistan in 2010 to that in 2012?
Provide a short and direct response. 1. What is the ratio of the Area (in %) of Lesotho in 2011 to that in 2012?
Offer a very short reply. 1.01. What is the difference between the highest and the second highest Area (in %) in Lesotho?
Keep it short and to the point. 0.76. What is the difference between the highest and the second highest Area (in %) of Marshall Islands?
Provide a short and direct response. 0. What is the difference between the highest and the second highest Area (in %) in Turkmenistan?
Provide a succinct answer. 0.32. What is the difference between the highest and the lowest Area (in %) in Croatia?
Your answer should be very brief. 2.36. What is the difference between the highest and the lowest Area (in %) of Lesotho?
Give a very brief answer. 2.53. What is the difference between the highest and the lowest Area (in %) in Marshall Islands?
Provide a succinct answer. 5.56. What is the difference between the highest and the lowest Area (in %) in Turkmenistan?
Keep it short and to the point. 1.83. 